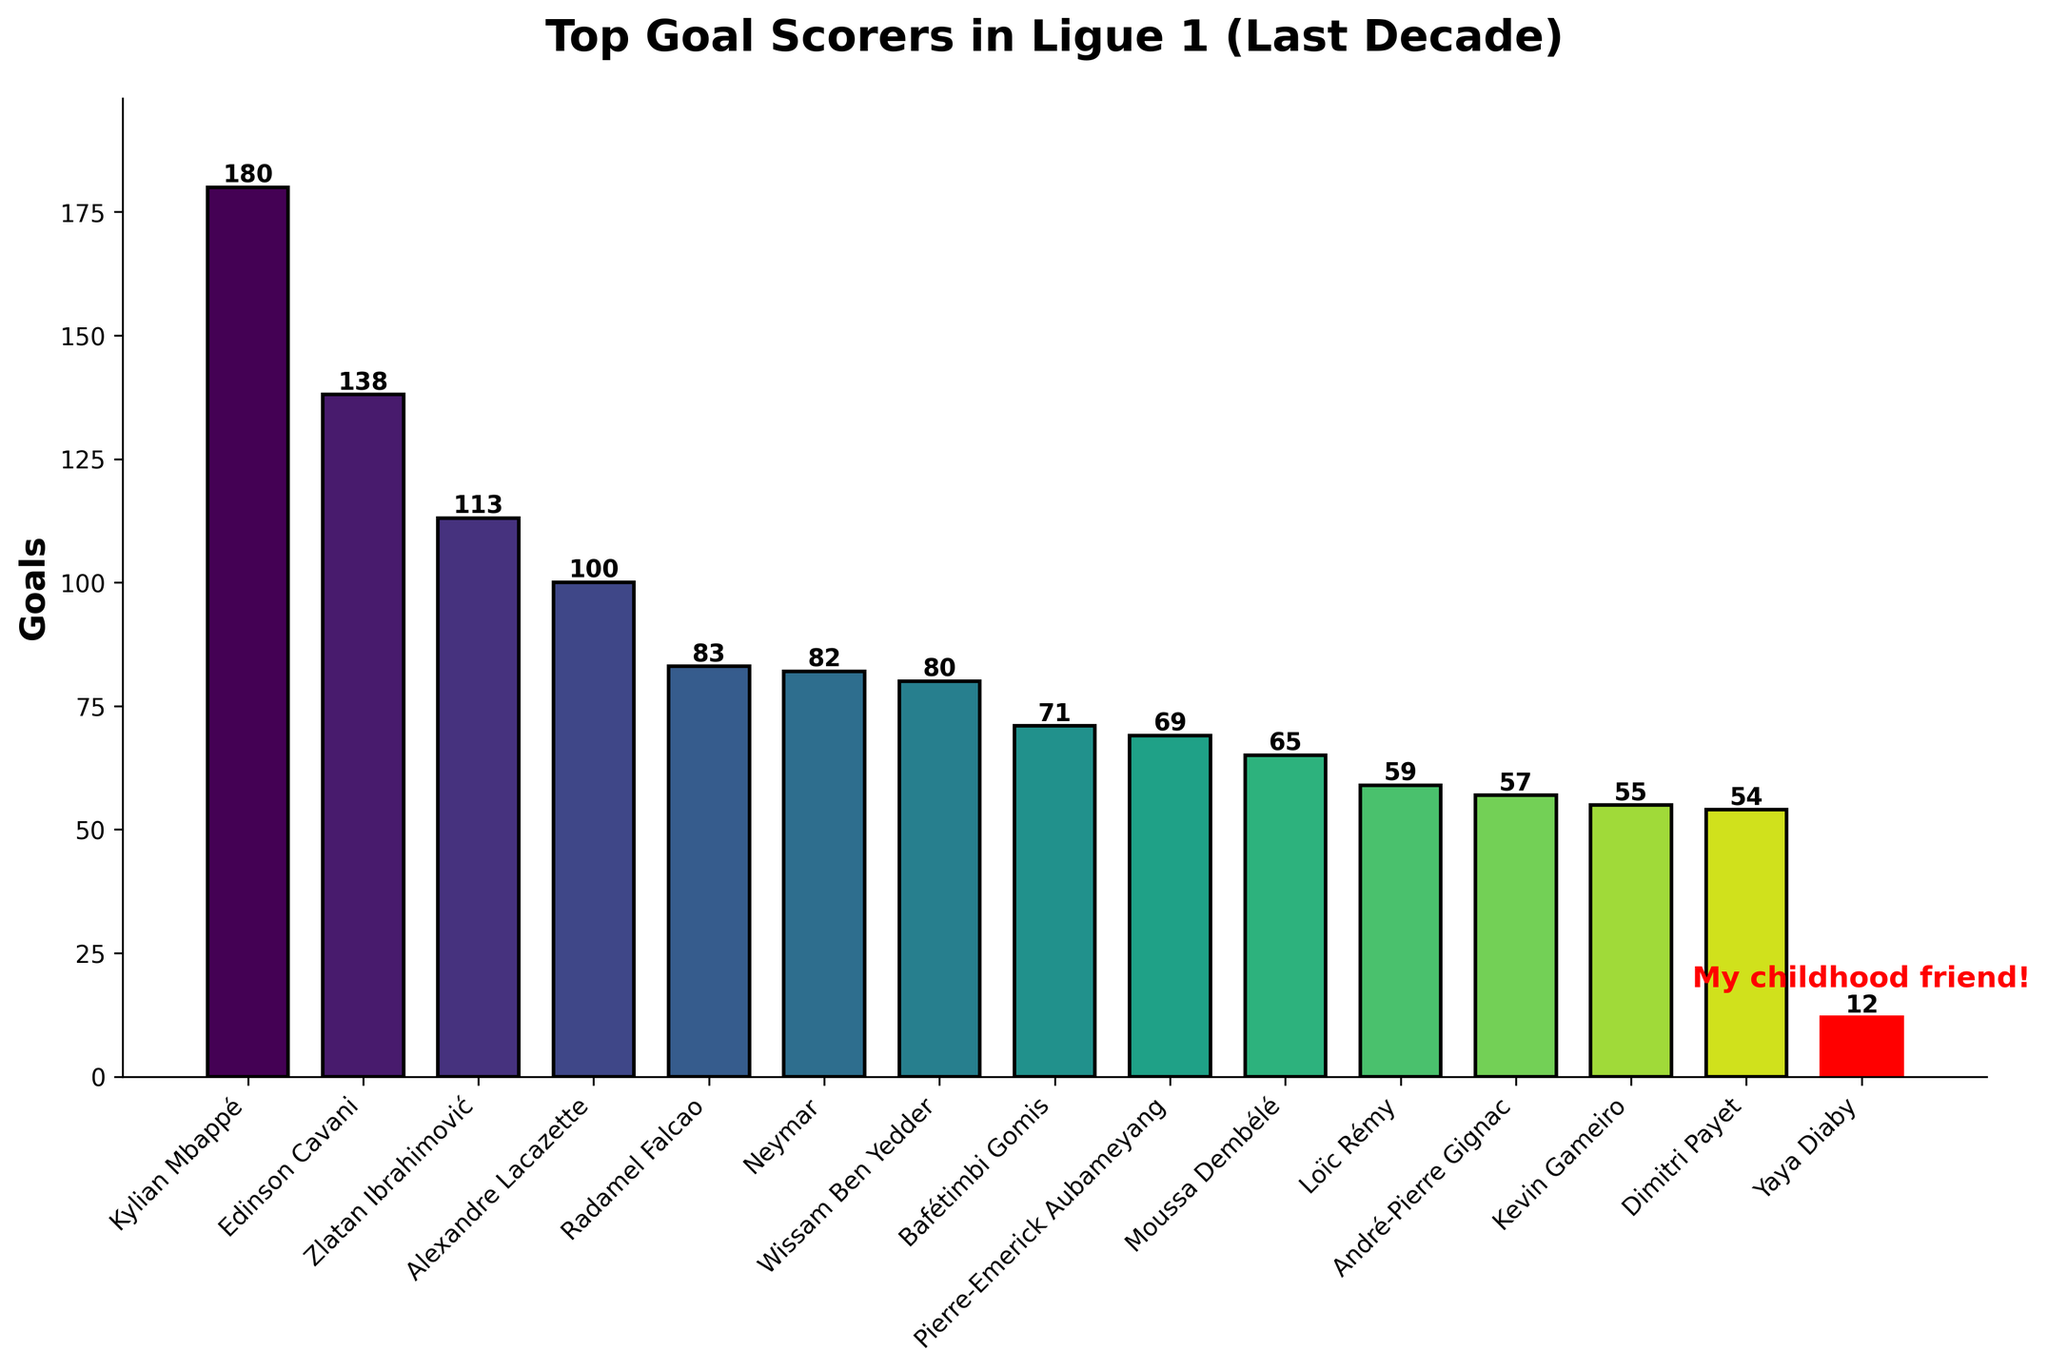Who is the top goal scorer in the Ligue 1 over the past decade? The top goal scorer can be identified by finding the player with the highest bar. Kylian Mbappé has the tallest bar.
Answer: Kylian Mbappé How many goals did Edinson Cavani score compared to Zlatan Ibrahimović? The heights of the bars for Edinson Cavani and Zlatan Ibrahimović need to be compared. Cavani's bar is at 138 goals and Ibrahimović's is at 113 goals. Subtract Ibrahimović's goals from Cavani's goals (138 - 113).
Answer: 25 Who scored more goals: Alexandre Lacazette or Neymar? By comparing the heights of the bars for Alexandre Lacazette and Neymar, it is clear that Lacazette has a bar of 100 goals while Neymar's bar is at 82 goals.
Answer: Alexandre Lacazette What are the total goals scored by Radamel Falcao, Wissam Ben Yedder, and Bafétimbi Gomis combined? Sum the heights of the bars for Radamel Falcao (83), Wissam Ben Yedder (80), and Bafétimbi Gomis (71). The total is calculated as 83 + 80 + 71.
Answer: 234 Who is your childhood friend and how many goals did he score? In the visual, the player's bar highlighted in red with the additional text “My childhood friend!” indicates my childhood friend. This bar is for Yaya Diaby, who scored 12 goals.
Answer: Yaya Diaby (12) Which player scored fewer goals: Loïc Rémy or Moussa Dembélé? By comparing the heights of the bars for Loïc Rémy and Moussa Dembélé, it's clear that Loïc Rémy has a bar at 59 goals while Moussa Dembélé has a bar at 65 goals.
Answer: Loïc Rémy What is the difference in goals between the top scorer and the lowest scorer? Identify the highest and lowest bars. The top scorer is Kylian Mbappé with 180 goals and the lowest scorer (in the list) is Yaya Diaby with 12 goals. The difference is calculated as 180 - 12.
Answer: 168 What percentage of Kylian Mbappé's goals is equivalent to Neymar's goals? First, find the number of goals Neymar scored, which is 82. Then, use the formula (Neymar's goals/Mbappé's goals) * 100, where Mbappé scored 180 goals. So, (82/180) * 100.
Answer: ~45.6% How many players scored 100 goals or more? Identify the bars that have heights greater than or equal to 100 goals. The players are Kylian Mbappé, Edinson Cavani, Zlatan Ibrahimović, and Alexandre Lacazette.
Answer: 4 Which players have bars with heights between 50 and 70 goals? Check the bars that fall between the range of 50 to 70 goals. The players falling in this range are Bafétimbi Gomis (71, slightly over 70), Pierre-Emerick Aubameyang (69), Moussa Dembélé (65), Loïc Rémy (59), and André-Pierre Gignac (57).
Answer: Bafétimbi Gomis, Pierre-Emerick Aubameyang, Moussa Dembélé, Loïc Rémy, André-Pierre Gignac 